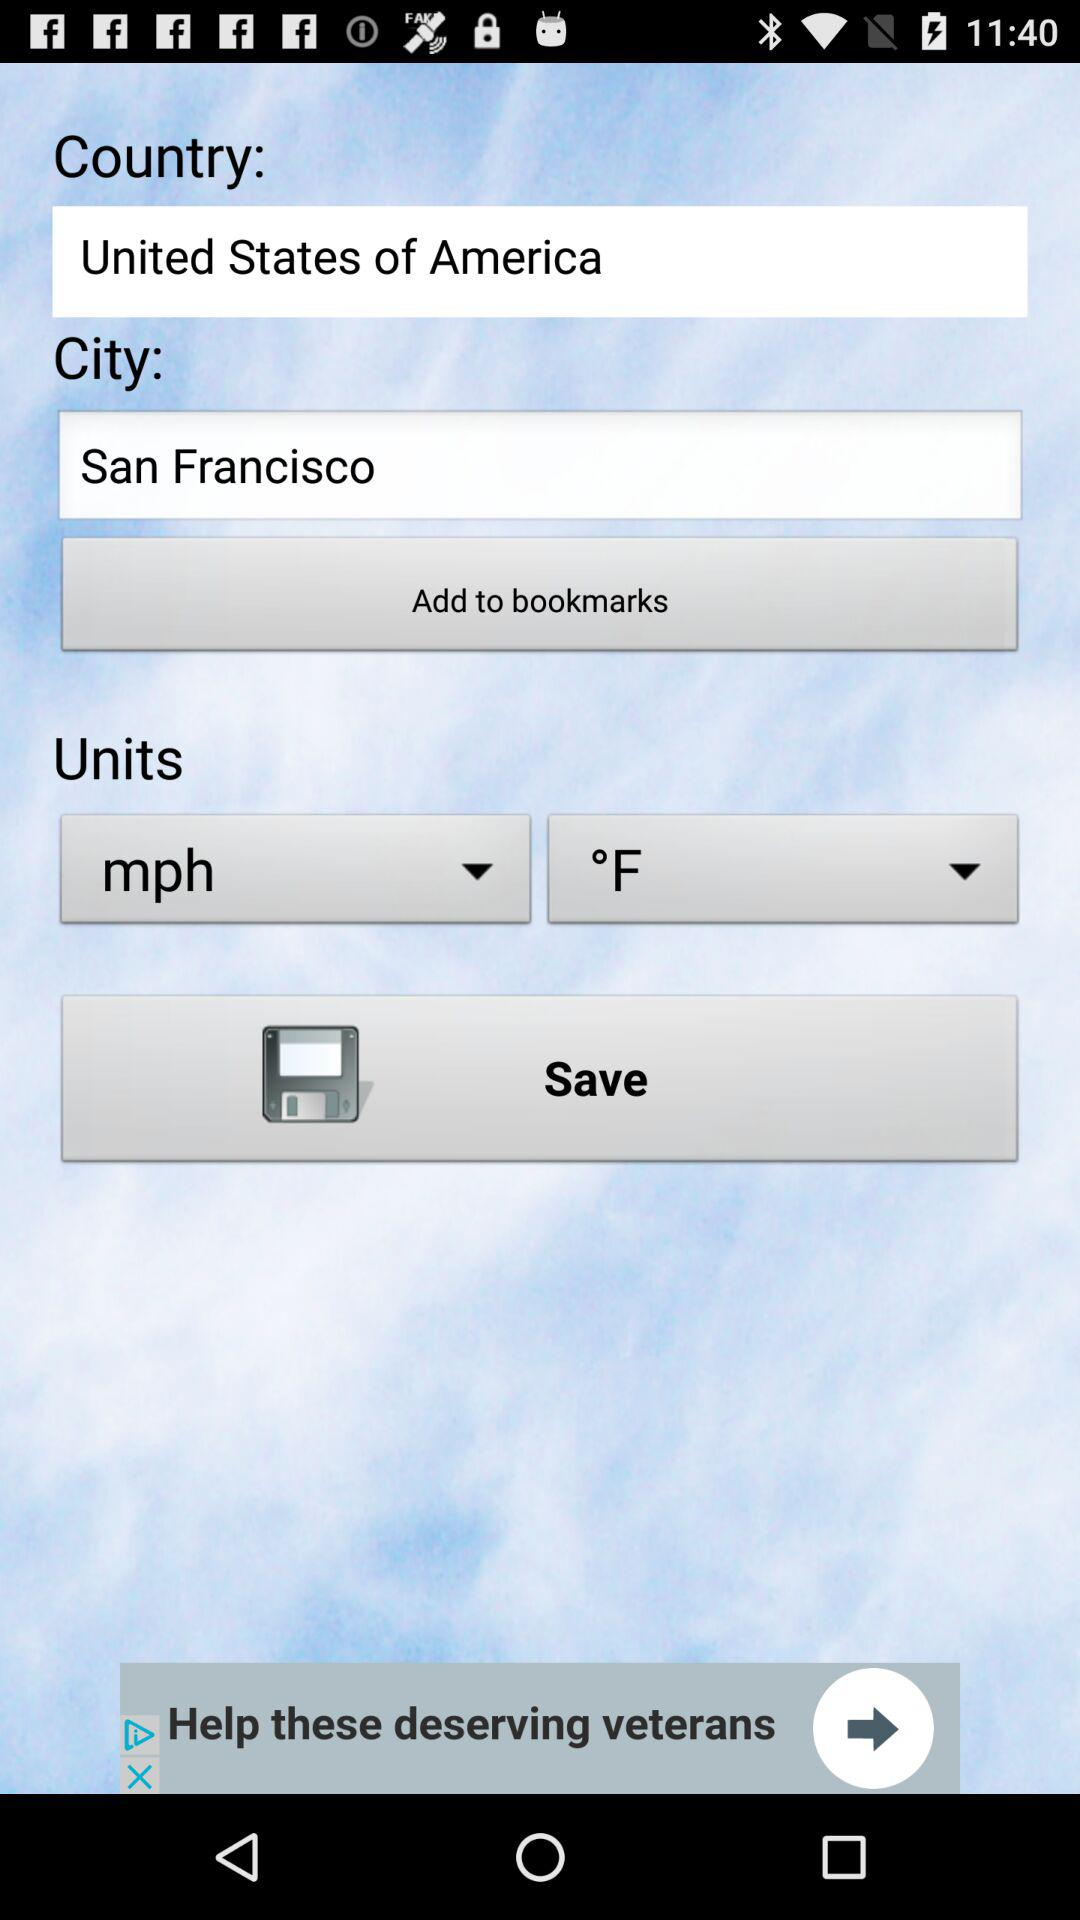Which country has been selected? The country that has been selected is the United States of America. 